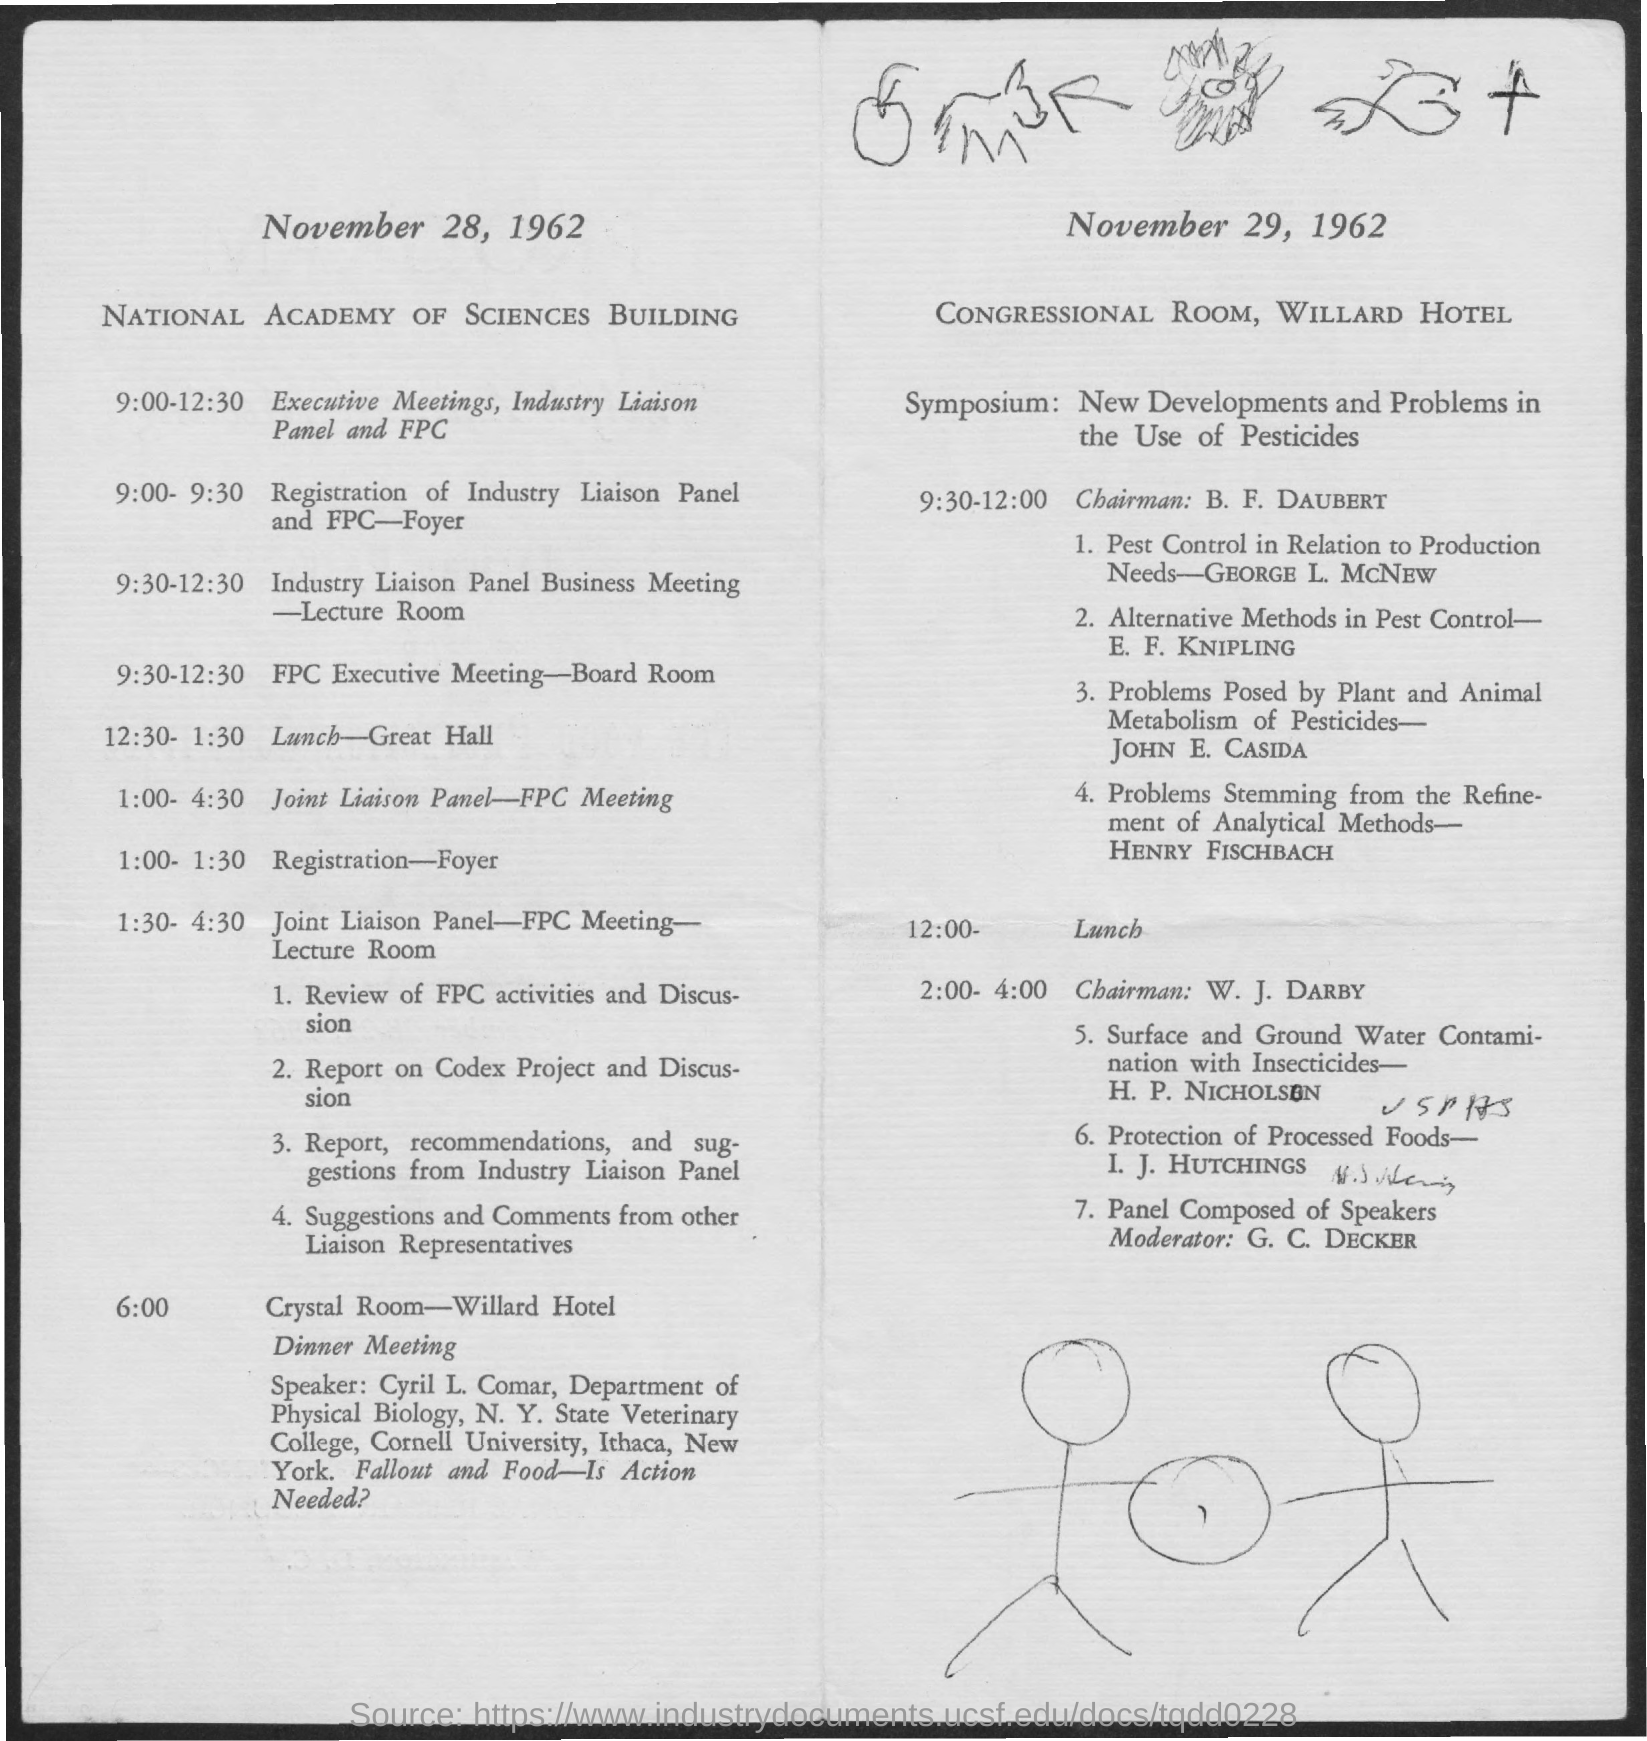Mention a couple of crucial points in this snapshot. On November 28, 1962, the meeting was held at the National Academy of Sciences Building. On November 28, 1962, Cyril L. Comar was the speaker at the dinner meeting. On November 28, 1962, the dinner meeting took place in the Crystal Room of the Willard Hotel. On November 29, 1962, the meeting was held at the Congressional Room of the Willard Hotel. On November 28, 1962, the lunch was held at the Great Hall. 